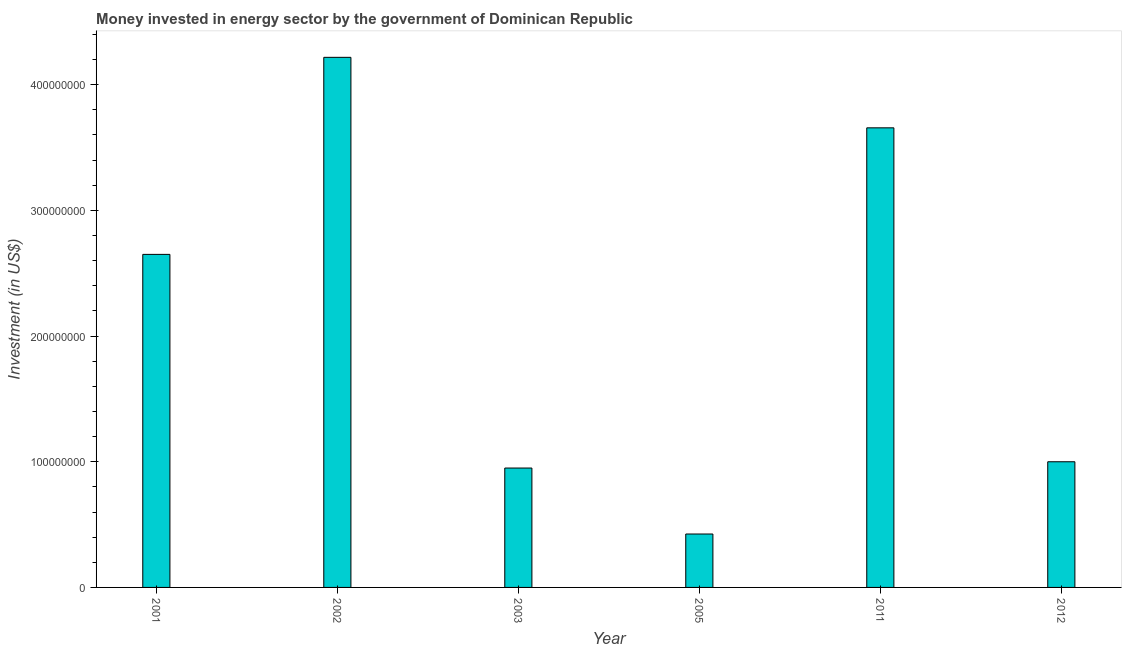What is the title of the graph?
Provide a succinct answer. Money invested in energy sector by the government of Dominican Republic. What is the label or title of the Y-axis?
Ensure brevity in your answer.  Investment (in US$). What is the investment in energy in 2005?
Your answer should be compact. 4.25e+07. Across all years, what is the maximum investment in energy?
Make the answer very short. 4.22e+08. Across all years, what is the minimum investment in energy?
Give a very brief answer. 4.25e+07. In which year was the investment in energy maximum?
Offer a very short reply. 2002. What is the sum of the investment in energy?
Your answer should be compact. 1.29e+09. What is the difference between the investment in energy in 2001 and 2011?
Offer a very short reply. -1.01e+08. What is the average investment in energy per year?
Provide a short and direct response. 2.15e+08. What is the median investment in energy?
Your answer should be very brief. 1.82e+08. What is the ratio of the investment in energy in 2002 to that in 2005?
Make the answer very short. 9.93. Is the difference between the investment in energy in 2001 and 2003 greater than the difference between any two years?
Keep it short and to the point. No. What is the difference between the highest and the second highest investment in energy?
Ensure brevity in your answer.  5.61e+07. Is the sum of the investment in energy in 2001 and 2012 greater than the maximum investment in energy across all years?
Ensure brevity in your answer.  No. What is the difference between the highest and the lowest investment in energy?
Your response must be concise. 3.79e+08. How many bars are there?
Your answer should be very brief. 6. Are all the bars in the graph horizontal?
Give a very brief answer. No. How many years are there in the graph?
Give a very brief answer. 6. What is the difference between two consecutive major ticks on the Y-axis?
Ensure brevity in your answer.  1.00e+08. What is the Investment (in US$) in 2001?
Make the answer very short. 2.65e+08. What is the Investment (in US$) of 2002?
Ensure brevity in your answer.  4.22e+08. What is the Investment (in US$) in 2003?
Your answer should be very brief. 9.50e+07. What is the Investment (in US$) of 2005?
Offer a very short reply. 4.25e+07. What is the Investment (in US$) of 2011?
Give a very brief answer. 3.66e+08. What is the Investment (in US$) in 2012?
Your answer should be compact. 1.00e+08. What is the difference between the Investment (in US$) in 2001 and 2002?
Offer a very short reply. -1.57e+08. What is the difference between the Investment (in US$) in 2001 and 2003?
Provide a short and direct response. 1.70e+08. What is the difference between the Investment (in US$) in 2001 and 2005?
Your answer should be very brief. 2.22e+08. What is the difference between the Investment (in US$) in 2001 and 2011?
Provide a succinct answer. -1.01e+08. What is the difference between the Investment (in US$) in 2001 and 2012?
Your answer should be very brief. 1.65e+08. What is the difference between the Investment (in US$) in 2002 and 2003?
Your response must be concise. 3.27e+08. What is the difference between the Investment (in US$) in 2002 and 2005?
Offer a very short reply. 3.79e+08. What is the difference between the Investment (in US$) in 2002 and 2011?
Provide a short and direct response. 5.61e+07. What is the difference between the Investment (in US$) in 2002 and 2012?
Offer a very short reply. 3.22e+08. What is the difference between the Investment (in US$) in 2003 and 2005?
Provide a succinct answer. 5.25e+07. What is the difference between the Investment (in US$) in 2003 and 2011?
Keep it short and to the point. -2.71e+08. What is the difference between the Investment (in US$) in 2003 and 2012?
Your response must be concise. -5.00e+06. What is the difference between the Investment (in US$) in 2005 and 2011?
Your answer should be compact. -3.23e+08. What is the difference between the Investment (in US$) in 2005 and 2012?
Provide a short and direct response. -5.75e+07. What is the difference between the Investment (in US$) in 2011 and 2012?
Provide a short and direct response. 2.66e+08. What is the ratio of the Investment (in US$) in 2001 to that in 2002?
Offer a very short reply. 0.63. What is the ratio of the Investment (in US$) in 2001 to that in 2003?
Keep it short and to the point. 2.79. What is the ratio of the Investment (in US$) in 2001 to that in 2005?
Give a very brief answer. 6.24. What is the ratio of the Investment (in US$) in 2001 to that in 2011?
Provide a short and direct response. 0.72. What is the ratio of the Investment (in US$) in 2001 to that in 2012?
Provide a succinct answer. 2.65. What is the ratio of the Investment (in US$) in 2002 to that in 2003?
Your answer should be very brief. 4.44. What is the ratio of the Investment (in US$) in 2002 to that in 2005?
Ensure brevity in your answer.  9.93. What is the ratio of the Investment (in US$) in 2002 to that in 2011?
Your response must be concise. 1.15. What is the ratio of the Investment (in US$) in 2002 to that in 2012?
Offer a terse response. 4.22. What is the ratio of the Investment (in US$) in 2003 to that in 2005?
Give a very brief answer. 2.23. What is the ratio of the Investment (in US$) in 2003 to that in 2011?
Provide a short and direct response. 0.26. What is the ratio of the Investment (in US$) in 2003 to that in 2012?
Offer a very short reply. 0.95. What is the ratio of the Investment (in US$) in 2005 to that in 2011?
Your answer should be compact. 0.12. What is the ratio of the Investment (in US$) in 2005 to that in 2012?
Give a very brief answer. 0.42. What is the ratio of the Investment (in US$) in 2011 to that in 2012?
Your answer should be very brief. 3.66. 